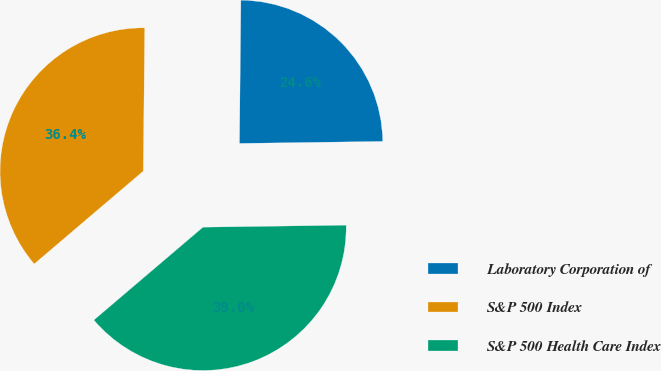Convert chart. <chart><loc_0><loc_0><loc_500><loc_500><pie_chart><fcel>Laboratory Corporation of<fcel>S&P 500 Index<fcel>S&P 500 Health Care Index<nl><fcel>24.62%<fcel>36.38%<fcel>39.0%<nl></chart> 